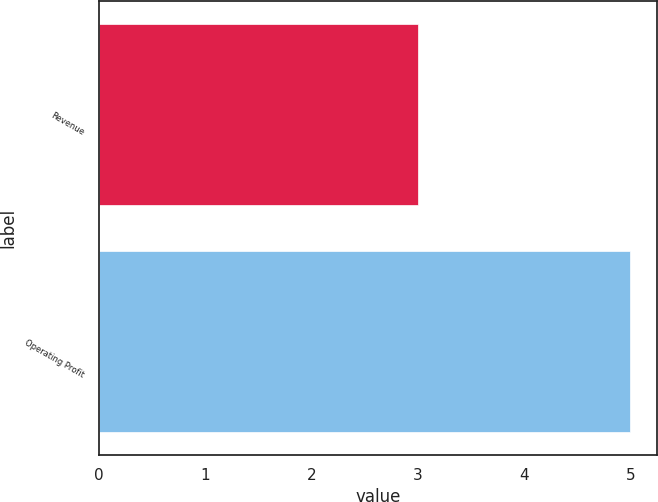<chart> <loc_0><loc_0><loc_500><loc_500><bar_chart><fcel>Revenue<fcel>Operating Profit<nl><fcel>3<fcel>5<nl></chart> 